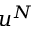<formula> <loc_0><loc_0><loc_500><loc_500>u ^ { N }</formula> 